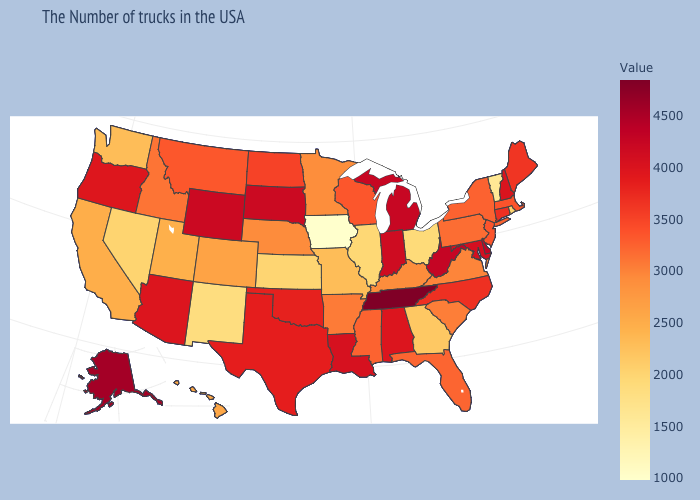Among the states that border Pennsylvania , does Ohio have the lowest value?
Give a very brief answer. Yes. Among the states that border Idaho , does Nevada have the lowest value?
Quick response, please. Yes. Does Kansas have the lowest value in the USA?
Be succinct. No. Which states have the lowest value in the Northeast?
Concise answer only. Vermont. Does North Carolina have the lowest value in the South?
Keep it brief. No. Does the map have missing data?
Be succinct. No. Does the map have missing data?
Write a very short answer. No. 